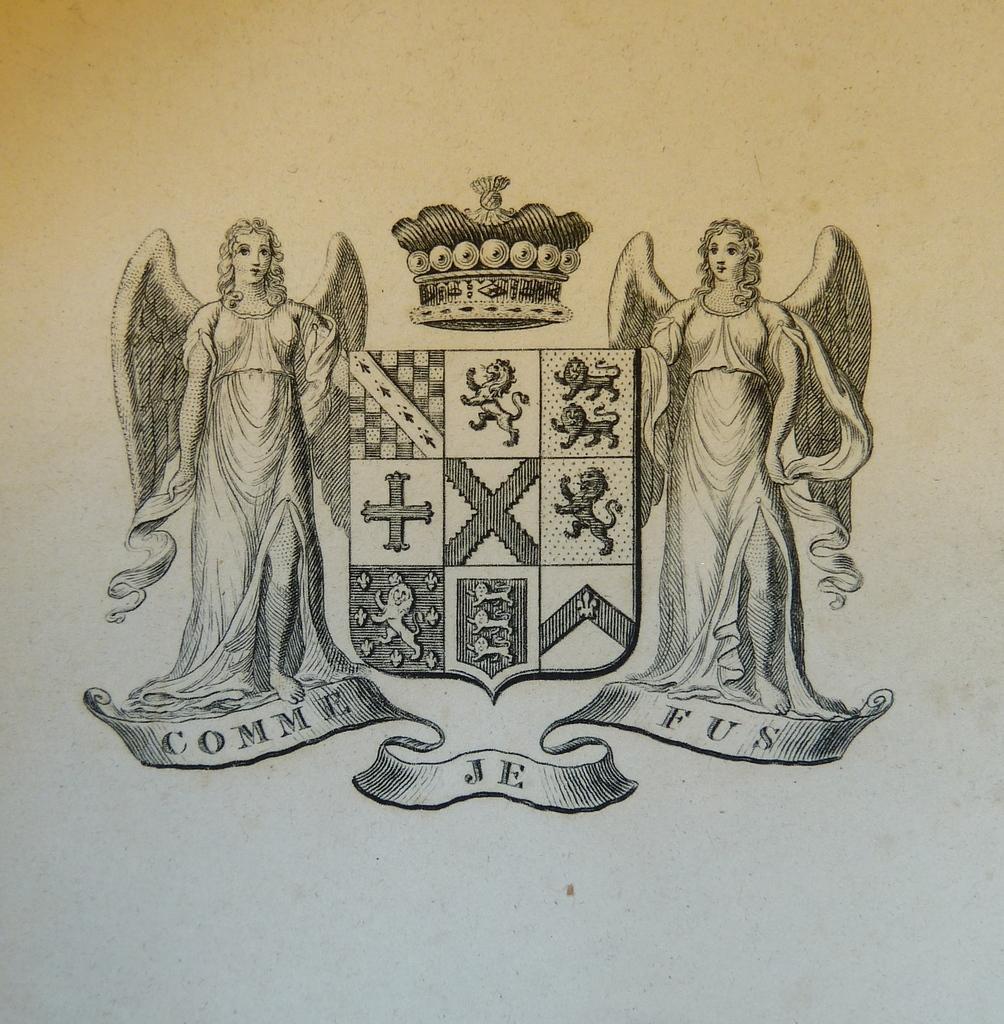Could you give a brief overview of what you see in this image? In this image, we can see some sketch on the white surface. Here we can see two people, crown, few symbols. 